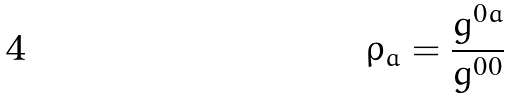<formula> <loc_0><loc_0><loc_500><loc_500>\rho _ { a } = \frac { g ^ { 0 a } } { g ^ { 0 0 } }</formula> 